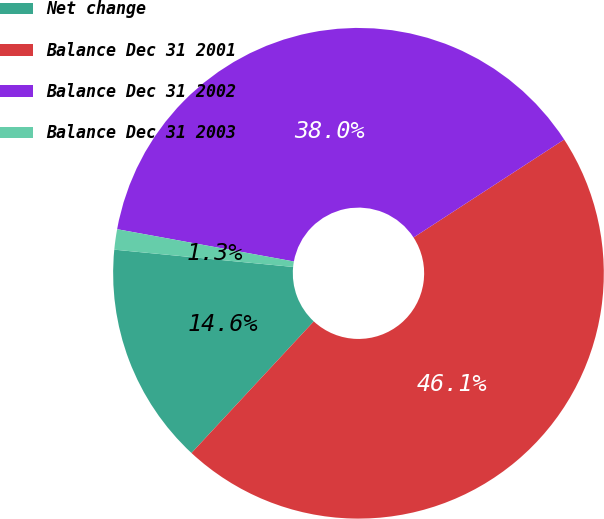<chart> <loc_0><loc_0><loc_500><loc_500><pie_chart><fcel>Net change<fcel>Balance Dec 31 2001<fcel>Balance Dec 31 2002<fcel>Balance Dec 31 2003<nl><fcel>14.62%<fcel>46.09%<fcel>37.95%<fcel>1.34%<nl></chart> 